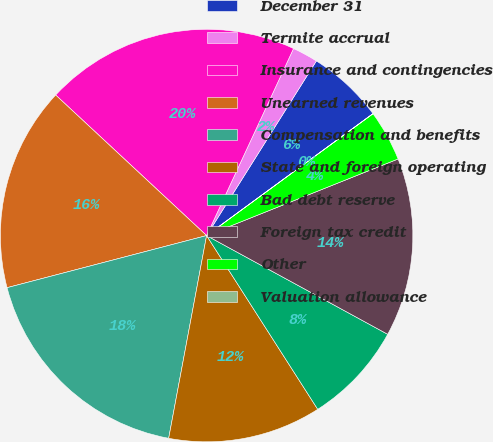Convert chart. <chart><loc_0><loc_0><loc_500><loc_500><pie_chart><fcel>December 31<fcel>Termite accrual<fcel>Insurance and contingencies<fcel>Unearned revenues<fcel>Compensation and benefits<fcel>State and foreign operating<fcel>Bad debt reserve<fcel>Foreign tax credit<fcel>Other<fcel>Valuation allowance<nl><fcel>6.0%<fcel>2.01%<fcel>19.99%<fcel>16.0%<fcel>17.99%<fcel>12.0%<fcel>8.0%<fcel>14.0%<fcel>4.0%<fcel>0.01%<nl></chart> 